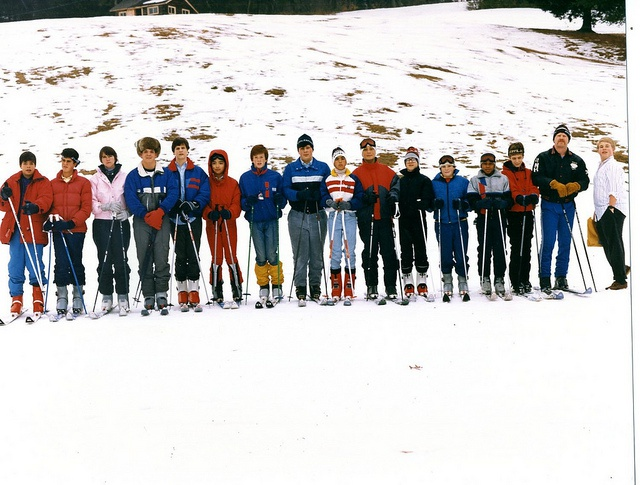Describe the objects in this image and their specific colors. I can see people in black, white, brown, and maroon tones, people in black, navy, and purple tones, people in black, navy, brown, and gray tones, people in black, blue, gray, and navy tones, and people in black, lavender, darkgray, and gray tones in this image. 